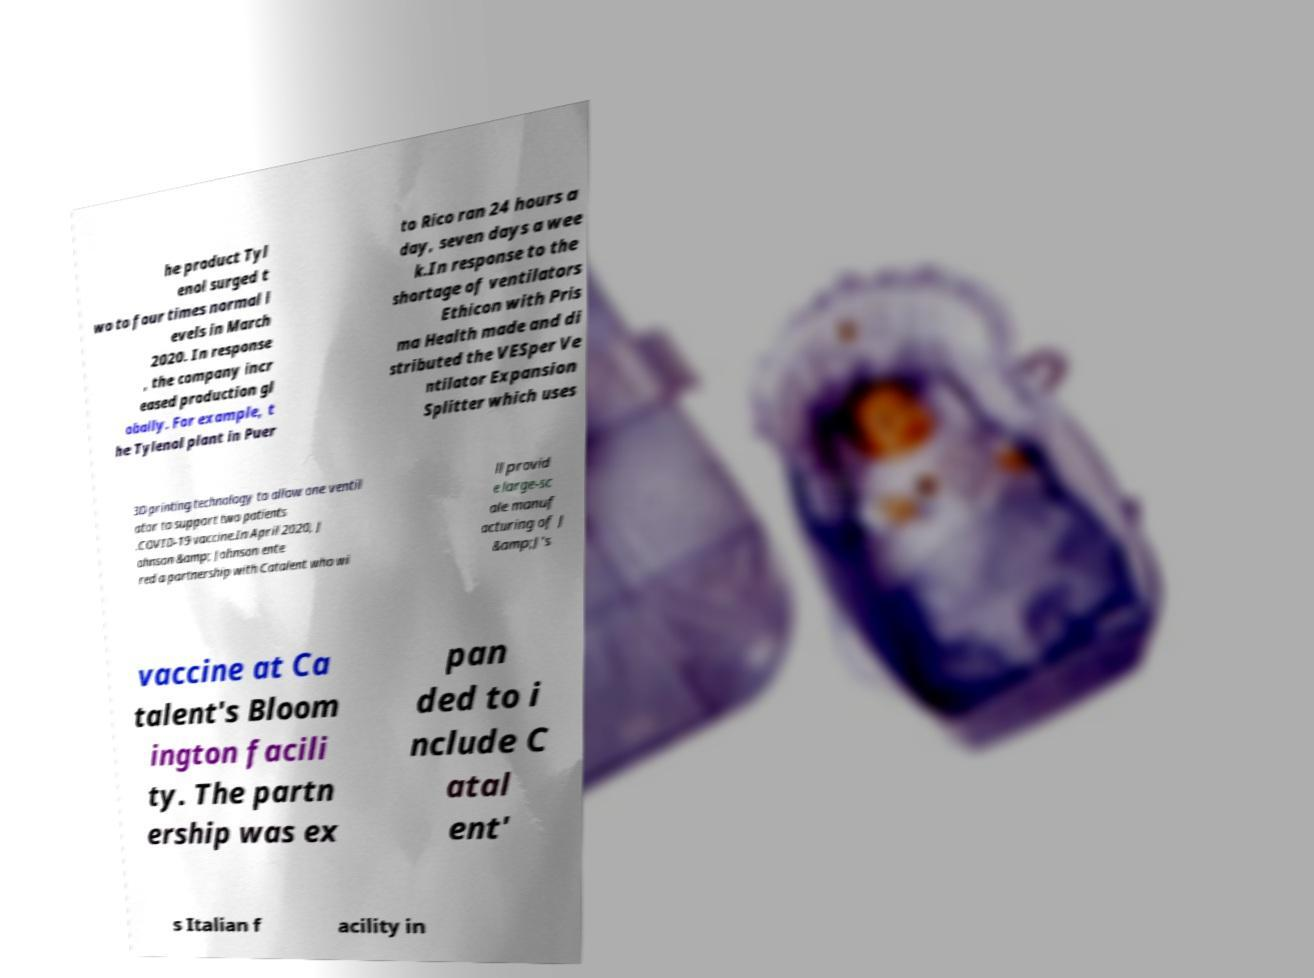Please identify and transcribe the text found in this image. he product Tyl enol surged t wo to four times normal l evels in March 2020. In response , the company incr eased production gl obally. For example, t he Tylenol plant in Puer to Rico ran 24 hours a day, seven days a wee k.In response to the shortage of ventilators Ethicon with Pris ma Health made and di stributed the VESper Ve ntilator Expansion Splitter which uses 3D printing technology to allow one ventil ator to support two patients .COVID-19 vaccine.In April 2020, J ohnson &amp; Johnson ente red a partnership with Catalent who wi ll provid e large-sc ale manuf acturing of J &amp;J's vaccine at Ca talent's Bloom ington facili ty. The partn ership was ex pan ded to i nclude C atal ent' s Italian f acility in 